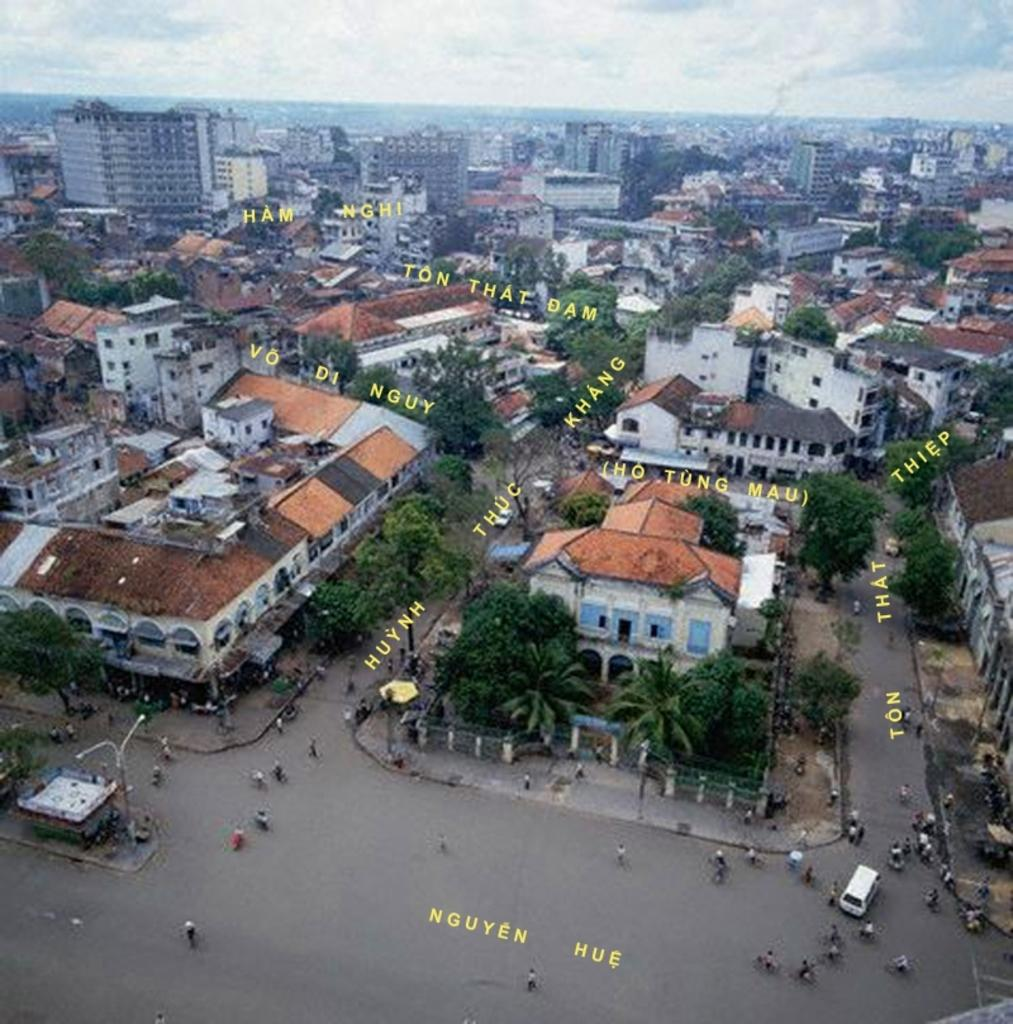What type of structures can be seen in the image? There are many buildings in the image. What natural elements are present in the image? There are trees in the image. What are the people in the image doing? There are people on the road in the image. Can you read any text in the image? Yes, there is some text visible in the image. What type of mitten is being used to set a new record in the image? There is no mitten or record-setting activity present in the image. 